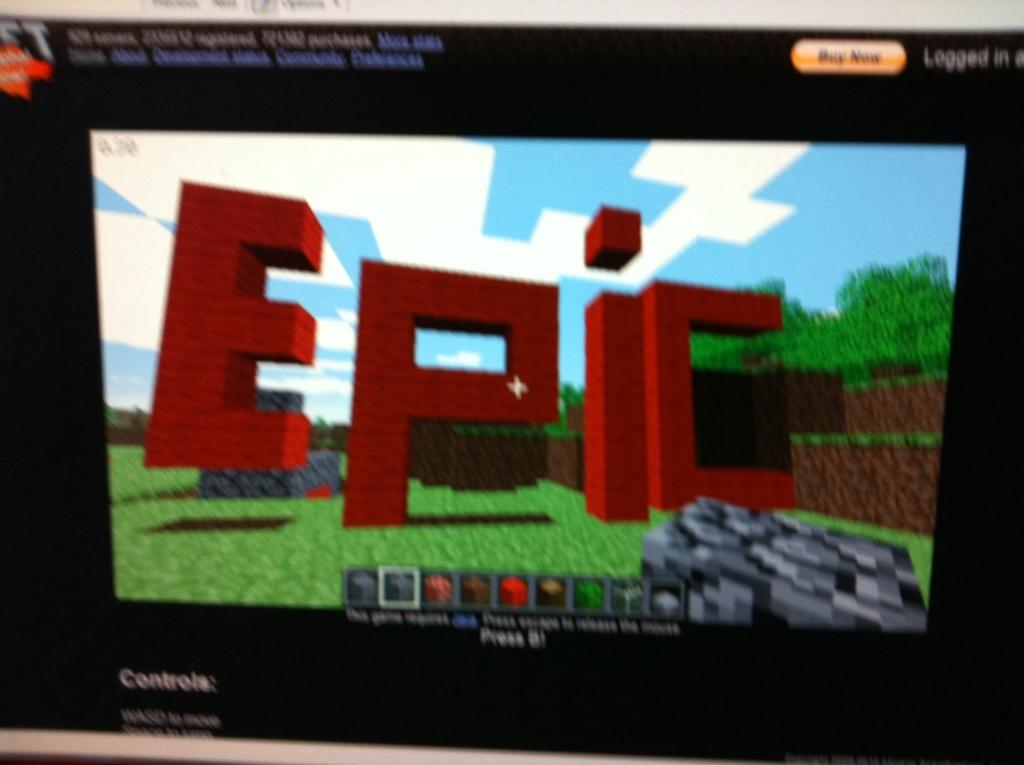Provide a one-sentence caption for the provided image. A computer display of a video with the word epic in red. 